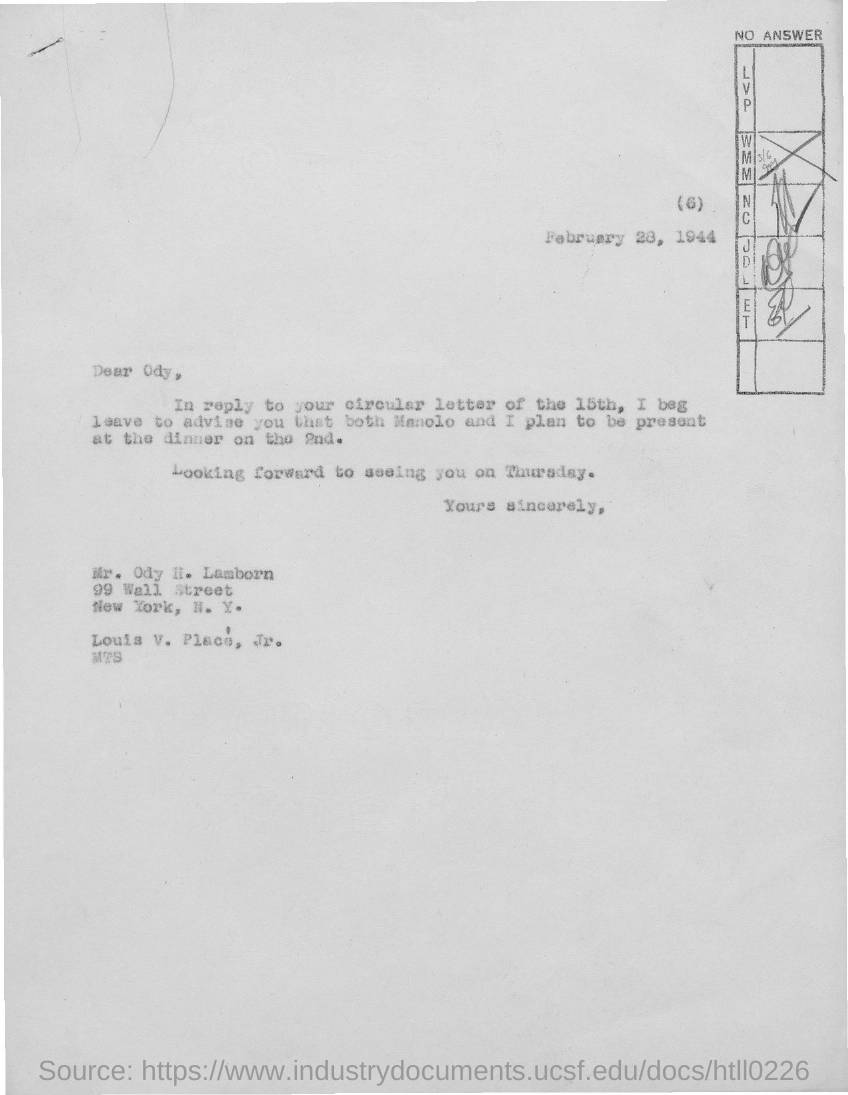Outline some significant characteristics in this image. The letter is addressed to the recipient, Odysseus. The dinner is scheduled for 2ND. The circular letter was dated 15th. The date on the document is February 28, 1944. 